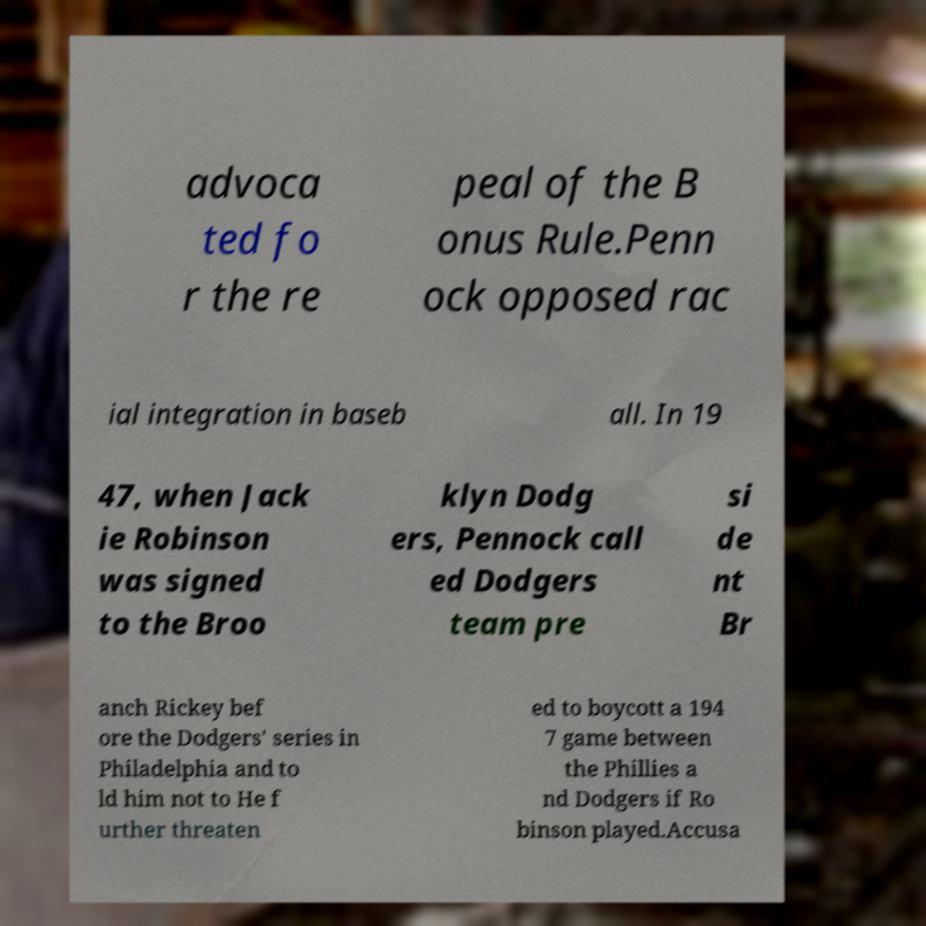For documentation purposes, I need the text within this image transcribed. Could you provide that? advoca ted fo r the re peal of the B onus Rule.Penn ock opposed rac ial integration in baseb all. In 19 47, when Jack ie Robinson was signed to the Broo klyn Dodg ers, Pennock call ed Dodgers team pre si de nt Br anch Rickey bef ore the Dodgers' series in Philadelphia and to ld him not to He f urther threaten ed to boycott a 194 7 game between the Phillies a nd Dodgers if Ro binson played.Accusa 